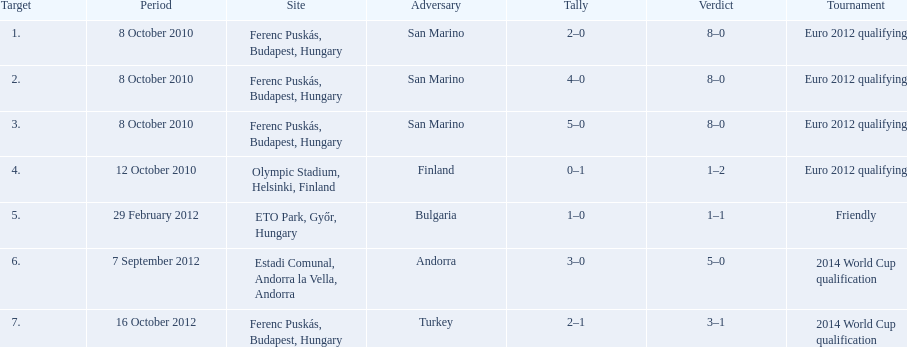What is the number of goals ádám szalai made against san marino in 2010? 3. 